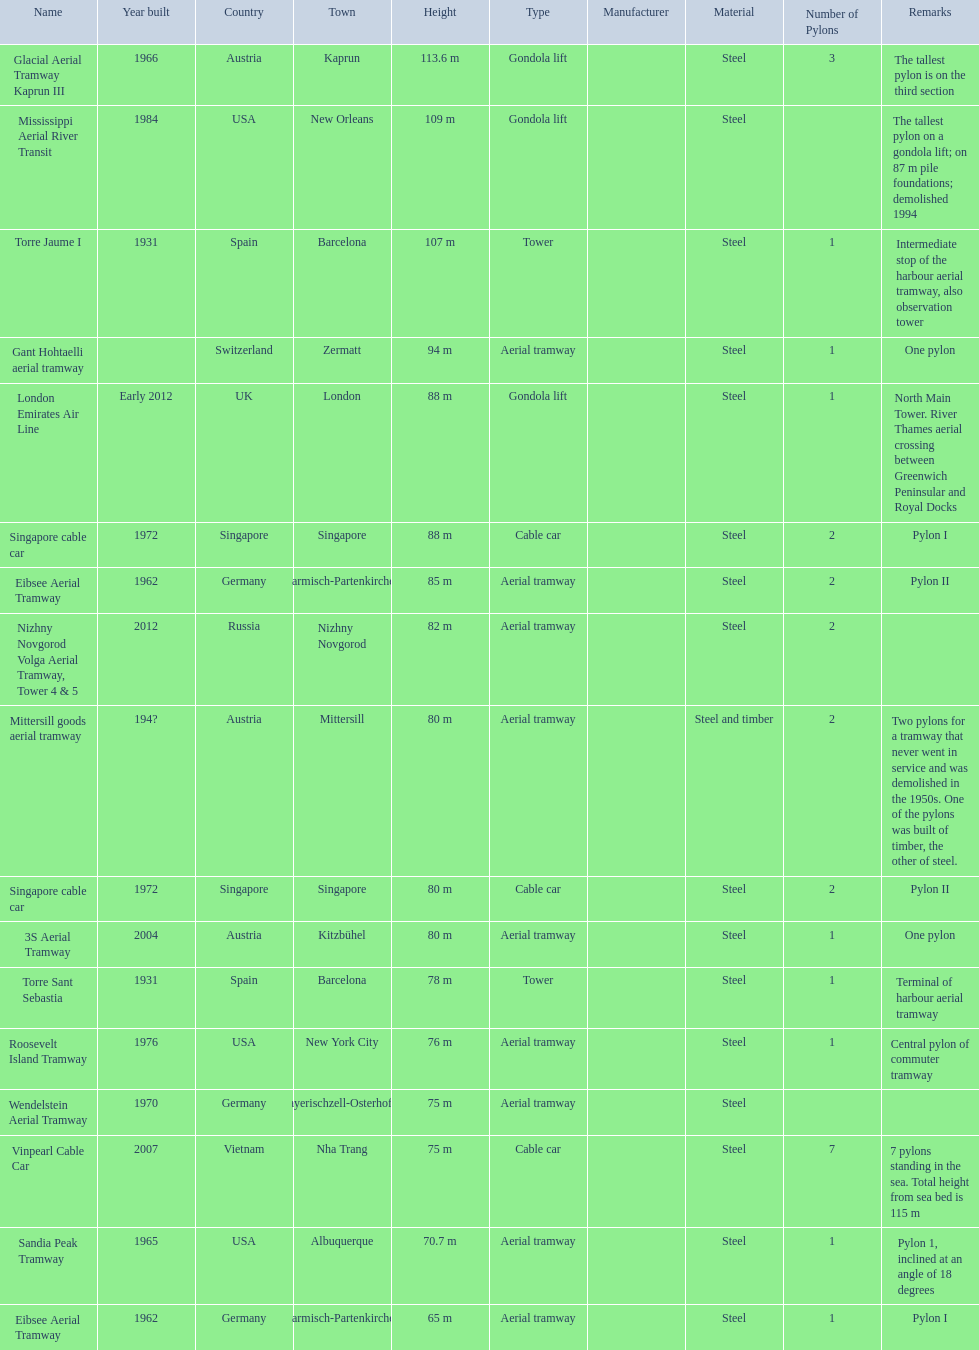Which aerial lifts are over 100 meters tall? Glacial Aerial Tramway Kaprun III, Mississippi Aerial River Transit, Torre Jaume I. Which of those was built last? Mississippi Aerial River Transit. And what is its total height? 109 m. 